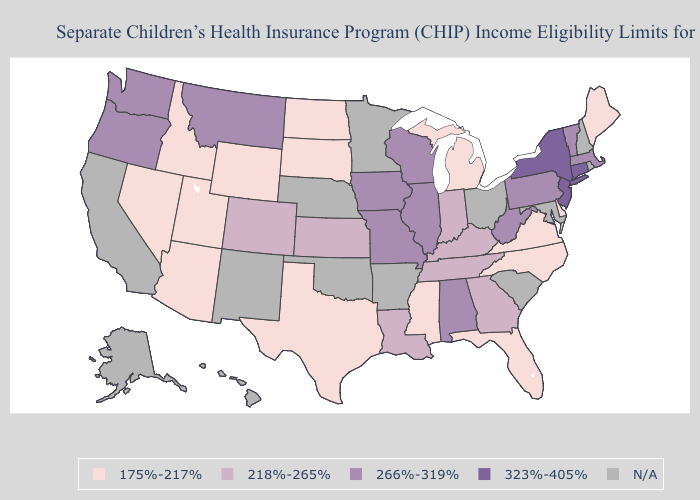Which states have the lowest value in the USA?
Be succinct. Arizona, Delaware, Florida, Idaho, Maine, Michigan, Mississippi, Nevada, North Carolina, North Dakota, South Dakota, Texas, Utah, Virginia, Wyoming. Name the states that have a value in the range 218%-265%?
Be succinct. Colorado, Georgia, Indiana, Kansas, Kentucky, Louisiana, Tennessee. Name the states that have a value in the range 218%-265%?
Give a very brief answer. Colorado, Georgia, Indiana, Kansas, Kentucky, Louisiana, Tennessee. Which states hav the highest value in the Northeast?
Quick response, please. Connecticut, New Jersey, New York. What is the value of New Mexico?
Quick response, please. N/A. Among the states that border Tennessee , which have the highest value?
Answer briefly. Alabama, Missouri. Name the states that have a value in the range N/A?
Write a very short answer. Alaska, Arkansas, California, Hawaii, Maryland, Minnesota, Nebraska, New Hampshire, New Mexico, Ohio, Oklahoma, Rhode Island, South Carolina. Among the states that border Maryland , which have the highest value?
Keep it brief. Pennsylvania, West Virginia. What is the value of North Carolina?
Quick response, please. 175%-217%. What is the lowest value in states that border Massachusetts?
Write a very short answer. 266%-319%. What is the lowest value in states that border Massachusetts?
Write a very short answer. 266%-319%. Does Connecticut have the highest value in the USA?
Short answer required. Yes. What is the value of Michigan?
Quick response, please. 175%-217%. Name the states that have a value in the range 175%-217%?
Give a very brief answer. Arizona, Delaware, Florida, Idaho, Maine, Michigan, Mississippi, Nevada, North Carolina, North Dakota, South Dakota, Texas, Utah, Virginia, Wyoming. Among the states that border Oregon , which have the highest value?
Short answer required. Washington. 